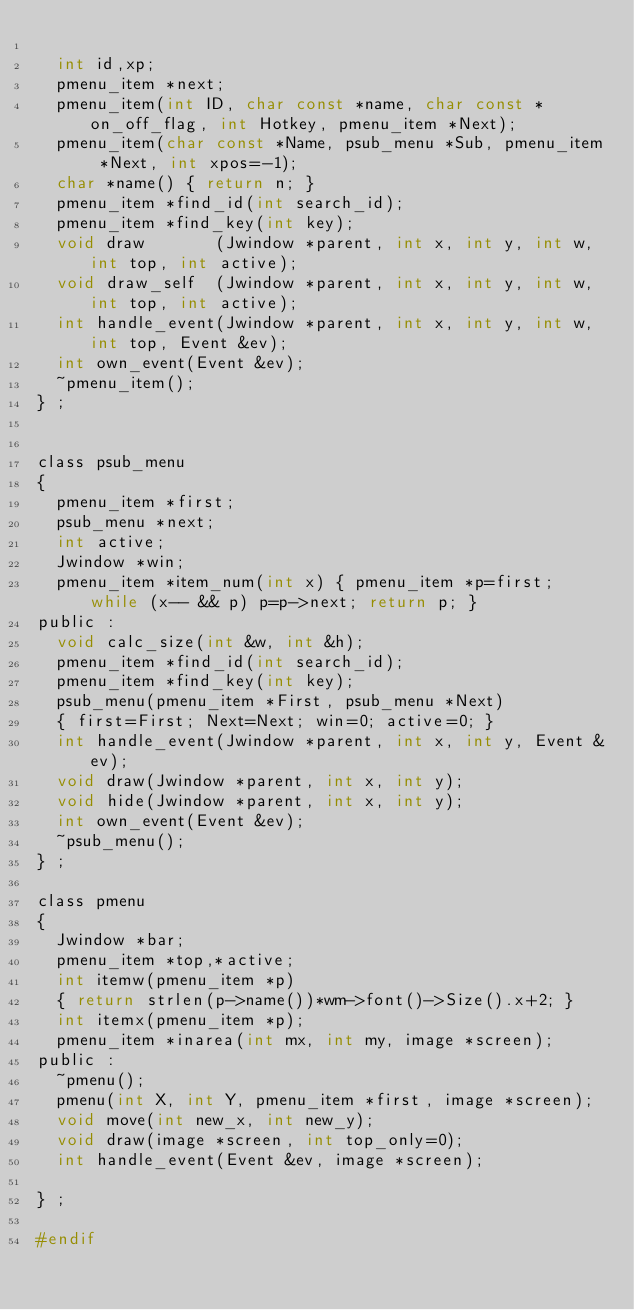Convert code to text. <code><loc_0><loc_0><loc_500><loc_500><_C_>
  int id,xp;
  pmenu_item *next;
  pmenu_item(int ID, char const *name, char const *on_off_flag, int Hotkey, pmenu_item *Next);
  pmenu_item(char const *Name, psub_menu *Sub, pmenu_item *Next, int xpos=-1);
  char *name() { return n; }
  pmenu_item *find_id(int search_id);
  pmenu_item *find_key(int key);
  void draw       (Jwindow *parent, int x, int y, int w, int top, int active);
  void draw_self  (Jwindow *parent, int x, int y, int w, int top, int active);
  int handle_event(Jwindow *parent, int x, int y, int w, int top, Event &ev);
  int own_event(Event &ev);
  ~pmenu_item();
} ;


class psub_menu
{
  pmenu_item *first;
  psub_menu *next;
  int active;
  Jwindow *win;
  pmenu_item *item_num(int x) { pmenu_item *p=first; while (x-- && p) p=p->next; return p; }
public :
  void calc_size(int &w, int &h);
  pmenu_item *find_id(int search_id);
  pmenu_item *find_key(int key);
  psub_menu(pmenu_item *First, psub_menu *Next)
  { first=First; Next=Next; win=0; active=0; }
  int handle_event(Jwindow *parent, int x, int y, Event &ev);
  void draw(Jwindow *parent, int x, int y);
  void hide(Jwindow *parent, int x, int y);
  int own_event(Event &ev);
  ~psub_menu();
} ;

class pmenu
{
  Jwindow *bar;
  pmenu_item *top,*active;
  int itemw(pmenu_item *p)
  { return strlen(p->name())*wm->font()->Size().x+2; }
  int itemx(pmenu_item *p);
  pmenu_item *inarea(int mx, int my, image *screen);
public :
  ~pmenu();
  pmenu(int X, int Y, pmenu_item *first, image *screen);
  void move(int new_x, int new_y);
  void draw(image *screen, int top_only=0);
  int handle_event(Event &ev, image *screen);

} ;

#endif


</code> 